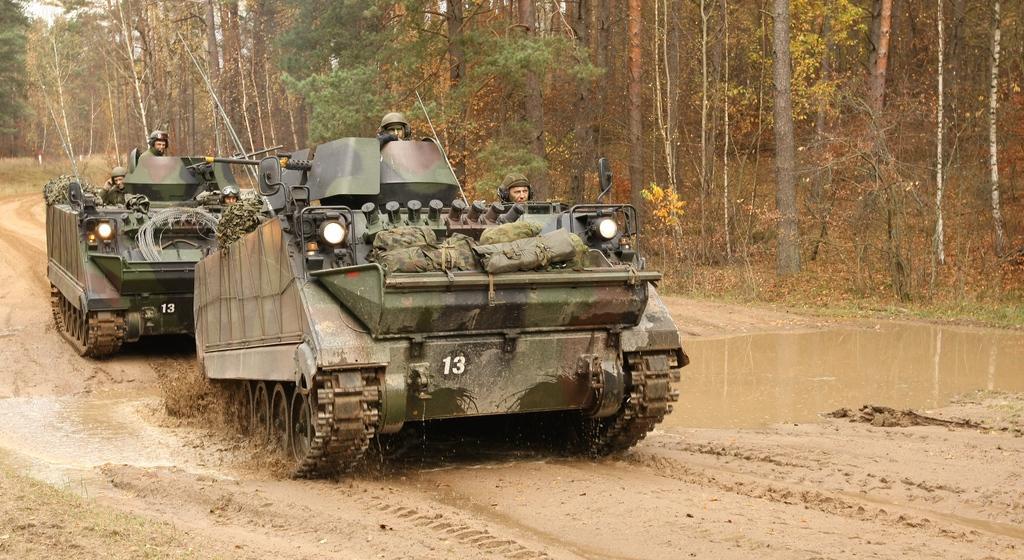How would you summarize this image in a sentence or two? In this image I see 2 tanks on which there are 4 persons and I see the lights and I see numbers on them and I see the mud and the water over here. In the background I see number of trees. 